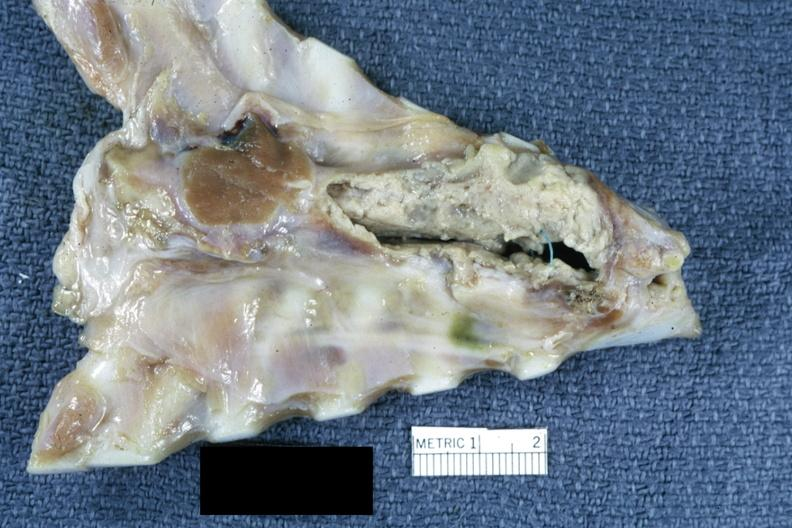s mediastinal abscess present?
Answer the question using a single word or phrase. Yes 